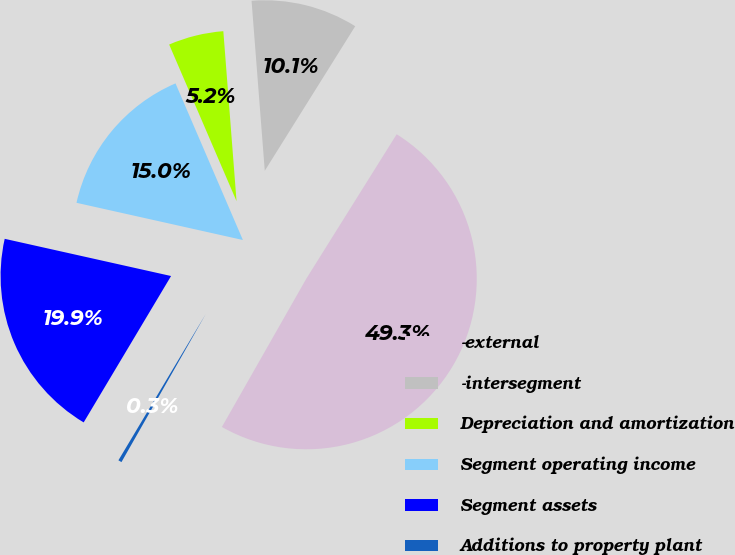Convert chart to OTSL. <chart><loc_0><loc_0><loc_500><loc_500><pie_chart><fcel>-external<fcel>-intersegment<fcel>Depreciation and amortization<fcel>Segment operating income<fcel>Segment assets<fcel>Additions to property plant<nl><fcel>49.33%<fcel>10.13%<fcel>5.23%<fcel>15.03%<fcel>19.93%<fcel>0.33%<nl></chart> 